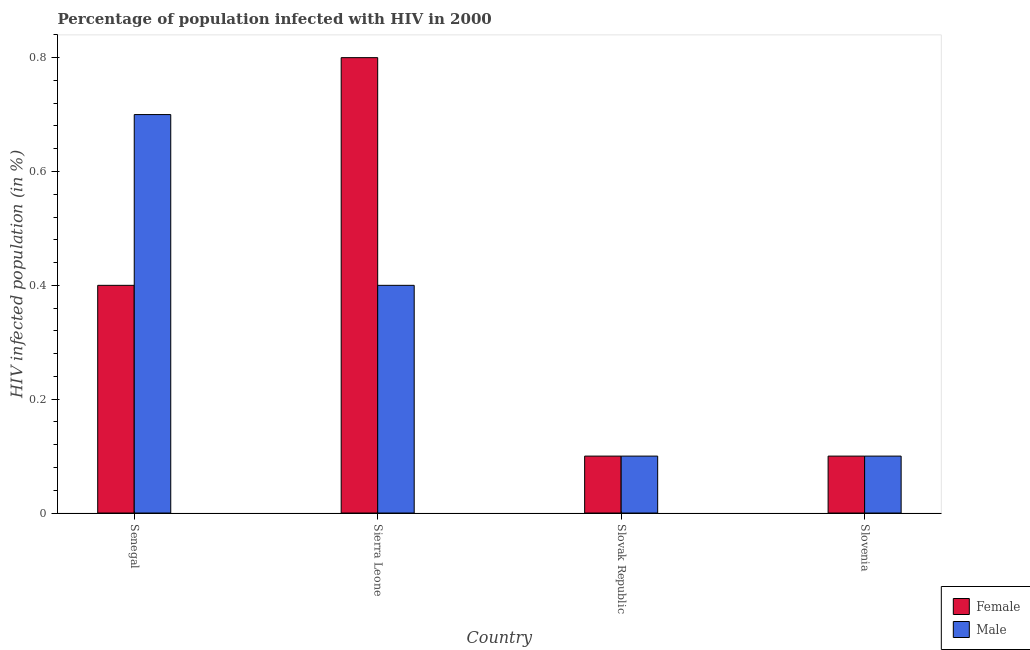How many different coloured bars are there?
Ensure brevity in your answer.  2. Are the number of bars on each tick of the X-axis equal?
Make the answer very short. Yes. How many bars are there on the 3rd tick from the right?
Ensure brevity in your answer.  2. What is the label of the 4th group of bars from the left?
Offer a terse response. Slovenia. In how many cases, is the number of bars for a given country not equal to the number of legend labels?
Give a very brief answer. 0. What is the percentage of females who are infected with hiv in Slovak Republic?
Your answer should be compact. 0.1. Across all countries, what is the minimum percentage of females who are infected with hiv?
Provide a short and direct response. 0.1. In which country was the percentage of females who are infected with hiv maximum?
Make the answer very short. Sierra Leone. In which country was the percentage of males who are infected with hiv minimum?
Ensure brevity in your answer.  Slovak Republic. What is the total percentage of males who are infected with hiv in the graph?
Keep it short and to the point. 1.3. What is the difference between the percentage of females who are infected with hiv in Sierra Leone and that in Slovenia?
Provide a succinct answer. 0.7. What is the difference between the percentage of males who are infected with hiv in Slovenia and the percentage of females who are infected with hiv in Sierra Leone?
Give a very brief answer. -0.7. What is the average percentage of males who are infected with hiv per country?
Provide a short and direct response. 0.33. In how many countries, is the percentage of females who are infected with hiv greater than 0.8 %?
Your answer should be very brief. 0. What is the ratio of the percentage of females who are infected with hiv in Senegal to that in Slovak Republic?
Your answer should be very brief. 4. What is the difference between the highest and the second highest percentage of females who are infected with hiv?
Ensure brevity in your answer.  0.4. What is the difference between the highest and the lowest percentage of males who are infected with hiv?
Make the answer very short. 0.6. What does the 2nd bar from the left in Slovak Republic represents?
Make the answer very short. Male. What does the 1st bar from the right in Slovak Republic represents?
Your answer should be compact. Male. Are all the bars in the graph horizontal?
Ensure brevity in your answer.  No. What is the difference between two consecutive major ticks on the Y-axis?
Make the answer very short. 0.2. Are the values on the major ticks of Y-axis written in scientific E-notation?
Make the answer very short. No. How are the legend labels stacked?
Provide a short and direct response. Vertical. What is the title of the graph?
Keep it short and to the point. Percentage of population infected with HIV in 2000. What is the label or title of the Y-axis?
Give a very brief answer. HIV infected population (in %). What is the HIV infected population (in %) in Female in Senegal?
Ensure brevity in your answer.  0.4. What is the HIV infected population (in %) of Male in Sierra Leone?
Give a very brief answer. 0.4. What is the HIV infected population (in %) of Female in Slovenia?
Provide a succinct answer. 0.1. What is the HIV infected population (in %) in Male in Slovenia?
Provide a succinct answer. 0.1. Across all countries, what is the minimum HIV infected population (in %) of Male?
Your answer should be very brief. 0.1. What is the total HIV infected population (in %) in Female in the graph?
Offer a terse response. 1.4. What is the difference between the HIV infected population (in %) in Male in Senegal and that in Sierra Leone?
Provide a short and direct response. 0.3. What is the difference between the HIV infected population (in %) of Female in Senegal and that in Slovak Republic?
Your answer should be very brief. 0.3. What is the difference between the HIV infected population (in %) in Female in Senegal and that in Slovenia?
Your response must be concise. 0.3. What is the difference between the HIV infected population (in %) of Male in Senegal and that in Slovenia?
Offer a very short reply. 0.6. What is the difference between the HIV infected population (in %) of Male in Sierra Leone and that in Slovak Republic?
Keep it short and to the point. 0.3. What is the difference between the HIV infected population (in %) in Female in Sierra Leone and that in Slovenia?
Provide a succinct answer. 0.7. What is the difference between the HIV infected population (in %) of Male in Sierra Leone and that in Slovenia?
Your response must be concise. 0.3. What is the difference between the HIV infected population (in %) of Female in Slovak Republic and that in Slovenia?
Your answer should be compact. 0. What is the difference between the HIV infected population (in %) in Female in Senegal and the HIV infected population (in %) in Male in Slovak Republic?
Ensure brevity in your answer.  0.3. What is the difference between the HIV infected population (in %) of Female in Senegal and the HIV infected population (in %) of Male in Slovenia?
Your answer should be compact. 0.3. What is the difference between the HIV infected population (in %) in Female in Sierra Leone and the HIV infected population (in %) in Male in Slovenia?
Your answer should be compact. 0.7. What is the difference between the HIV infected population (in %) in Female in Slovak Republic and the HIV infected population (in %) in Male in Slovenia?
Provide a succinct answer. 0. What is the average HIV infected population (in %) in Female per country?
Offer a terse response. 0.35. What is the average HIV infected population (in %) in Male per country?
Provide a short and direct response. 0.33. What is the difference between the HIV infected population (in %) in Female and HIV infected population (in %) in Male in Senegal?
Offer a terse response. -0.3. What is the difference between the HIV infected population (in %) in Female and HIV infected population (in %) in Male in Sierra Leone?
Offer a very short reply. 0.4. What is the difference between the HIV infected population (in %) in Female and HIV infected population (in %) in Male in Slovak Republic?
Give a very brief answer. 0. What is the difference between the HIV infected population (in %) in Female and HIV infected population (in %) in Male in Slovenia?
Offer a terse response. 0. What is the ratio of the HIV infected population (in %) of Female in Senegal to that in Slovak Republic?
Provide a succinct answer. 4. What is the ratio of the HIV infected population (in %) in Female in Sierra Leone to that in Slovak Republic?
Your answer should be compact. 8. What is the ratio of the HIV infected population (in %) of Male in Sierra Leone to that in Slovak Republic?
Offer a terse response. 4. What is the ratio of the HIV infected population (in %) of Male in Sierra Leone to that in Slovenia?
Your answer should be compact. 4. What is the ratio of the HIV infected population (in %) of Female in Slovak Republic to that in Slovenia?
Your answer should be compact. 1. What is the ratio of the HIV infected population (in %) in Male in Slovak Republic to that in Slovenia?
Your response must be concise. 1. What is the difference between the highest and the second highest HIV infected population (in %) in Male?
Offer a terse response. 0.3. What is the difference between the highest and the lowest HIV infected population (in %) of Male?
Your response must be concise. 0.6. 